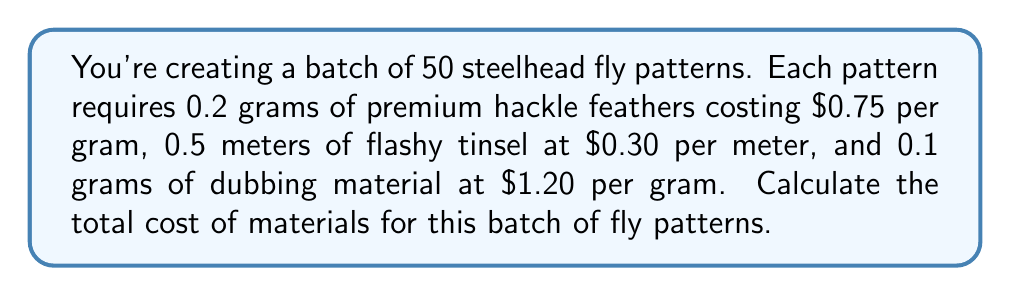Show me your answer to this math problem. Let's break this down step-by-step:

1. Calculate the cost of hackle feathers:
   - Each pattern uses 0.2 grams
   - For 50 patterns: $50 \times 0.2 = 10$ grams
   - Cost per gram is $0.75
   - Total cost: $10 \times $0.75 = $7.50

2. Calculate the cost of flashy tinsel:
   - Each pattern uses 0.5 meters
   - For 50 patterns: $50 \times 0.5 = 25$ meters
   - Cost per meter is $0.30
   - Total cost: $25 \times $0.30 = $7.50

3. Calculate the cost of dubbing material:
   - Each pattern uses 0.1 grams
   - For 50 patterns: $50 \times 0.1 = 5$ grams
   - Cost per gram is $1.20
   - Total cost: $5 \times $1.20 = $6.00

4. Sum up the total cost:
   $$ \text{Total Cost} = $7.50 + $7.50 + $6.00 = $21.00 $$
Answer: $21.00 